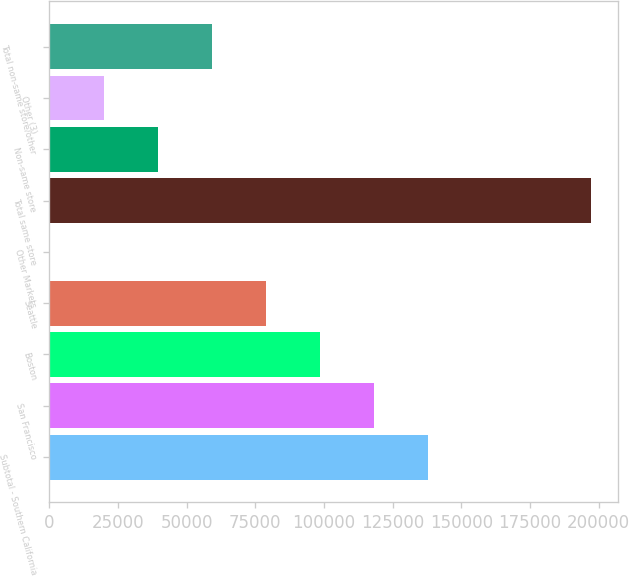<chart> <loc_0><loc_0><loc_500><loc_500><bar_chart><fcel>Subtotal - Southern California<fcel>San Francisco<fcel>Boston<fcel>Seattle<fcel>Other Markets<fcel>Total same store<fcel>Non-same store<fcel>Other (3)<fcel>Total non-same store/other<nl><fcel>138029<fcel>118325<fcel>98621.5<fcel>78917.8<fcel>103<fcel>197140<fcel>39510.4<fcel>19806.7<fcel>59214.1<nl></chart> 